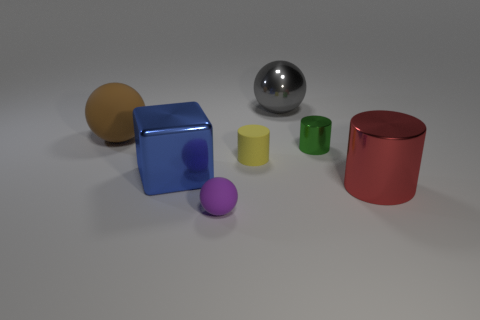There is a matte thing to the left of the matte object in front of the red metal thing; what shape is it?
Give a very brief answer. Sphere. What number of big gray balls are made of the same material as the gray thing?
Provide a succinct answer. 0. There is a thing in front of the red shiny cylinder; what is it made of?
Your answer should be compact. Rubber. What is the shape of the shiny object that is on the left side of the small rubber thing in front of the cylinder left of the metal ball?
Ensure brevity in your answer.  Cube. There is a large metallic ball right of the big brown sphere; does it have the same color as the large metallic thing that is on the right side of the big gray shiny ball?
Provide a short and direct response. No. Is the number of large metallic blocks to the left of the large shiny cube less than the number of red metallic cylinders that are on the left side of the tiny rubber cylinder?
Offer a very short reply. No. Is there anything else that has the same shape as the big blue object?
Make the answer very short. No. There is another tiny matte thing that is the same shape as the gray object; what color is it?
Your answer should be compact. Purple. There is a small purple object; does it have the same shape as the small rubber object behind the cube?
Give a very brief answer. No. How many things are either matte balls that are to the right of the blue object or big objects right of the brown object?
Provide a succinct answer. 4. 